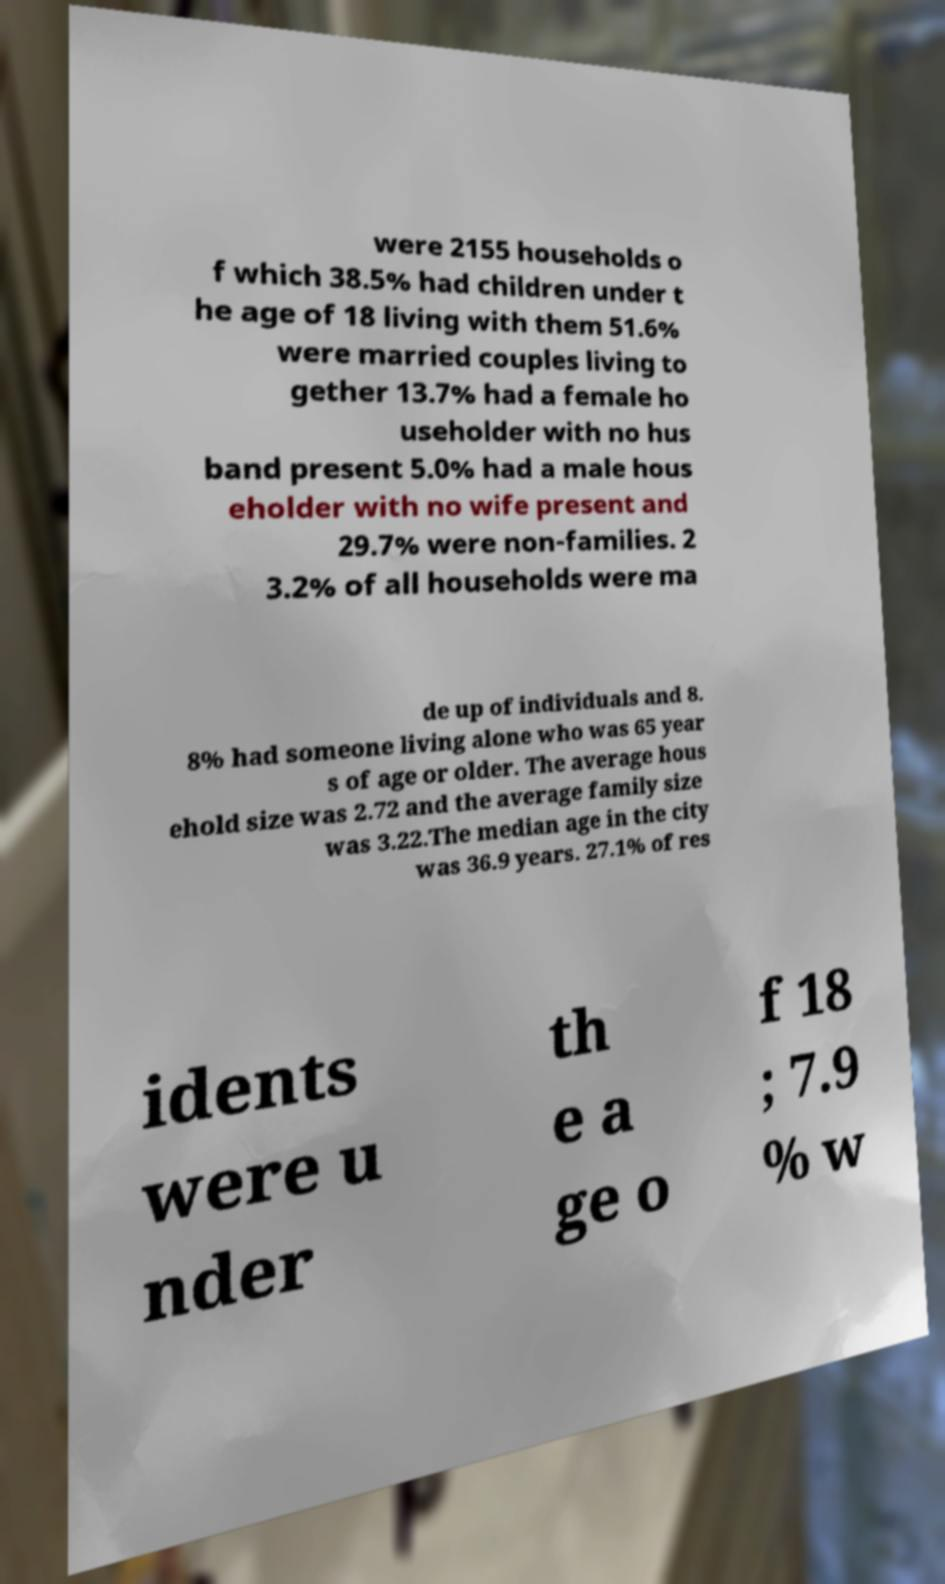I need the written content from this picture converted into text. Can you do that? were 2155 households o f which 38.5% had children under t he age of 18 living with them 51.6% were married couples living to gether 13.7% had a female ho useholder with no hus band present 5.0% had a male hous eholder with no wife present and 29.7% were non-families. 2 3.2% of all households were ma de up of individuals and 8. 8% had someone living alone who was 65 year s of age or older. The average hous ehold size was 2.72 and the average family size was 3.22.The median age in the city was 36.9 years. 27.1% of res idents were u nder th e a ge o f 18 ; 7.9 % w 